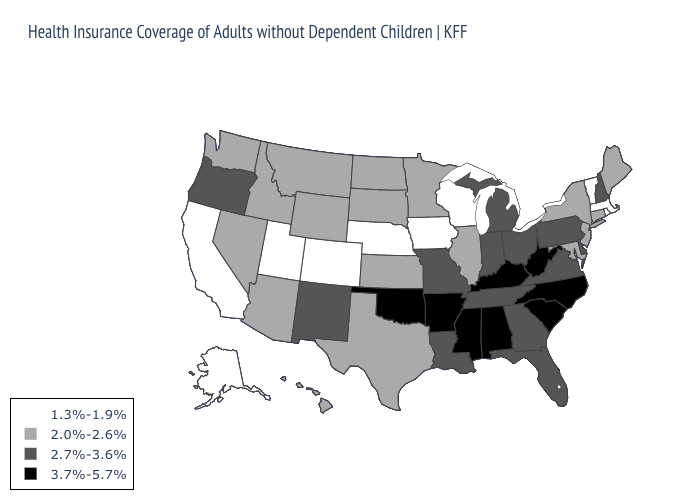Name the states that have a value in the range 2.7%-3.6%?
Concise answer only. Delaware, Florida, Georgia, Indiana, Louisiana, Michigan, Missouri, New Hampshire, New Mexico, Ohio, Oregon, Pennsylvania, Tennessee, Virginia. What is the value of New Hampshire?
Be succinct. 2.7%-3.6%. What is the lowest value in the West?
Write a very short answer. 1.3%-1.9%. What is the lowest value in states that border Colorado?
Concise answer only. 1.3%-1.9%. What is the lowest value in the South?
Be succinct. 2.0%-2.6%. What is the highest value in the Northeast ?
Give a very brief answer. 2.7%-3.6%. What is the highest value in the USA?
Short answer required. 3.7%-5.7%. Name the states that have a value in the range 3.7%-5.7%?
Concise answer only. Alabama, Arkansas, Kentucky, Mississippi, North Carolina, Oklahoma, South Carolina, West Virginia. What is the highest value in states that border Maryland?
Answer briefly. 3.7%-5.7%. Name the states that have a value in the range 3.7%-5.7%?
Be succinct. Alabama, Arkansas, Kentucky, Mississippi, North Carolina, Oklahoma, South Carolina, West Virginia. Name the states that have a value in the range 3.7%-5.7%?
Give a very brief answer. Alabama, Arkansas, Kentucky, Mississippi, North Carolina, Oklahoma, South Carolina, West Virginia. What is the lowest value in the Northeast?
Give a very brief answer. 1.3%-1.9%. Does Arkansas have the highest value in the USA?
Quick response, please. Yes. Name the states that have a value in the range 1.3%-1.9%?
Short answer required. Alaska, California, Colorado, Iowa, Massachusetts, Nebraska, Rhode Island, Utah, Vermont, Wisconsin. What is the lowest value in states that border Tennessee?
Concise answer only. 2.7%-3.6%. 